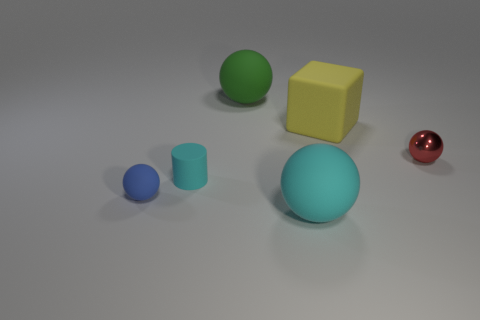What kind of textures are present on the surfaces of the objects? The objects exhibit different textures in the image. The cyan sphere and the yellow cube have a relatively smooth and matte texture. In contrast, the red sphere has a reflective surface that suggests a smoother and possibly metallic texture. The matte surfaces would diffuse light, while the glossy red sphere would reflect light, creating highlights and defined reflections. 